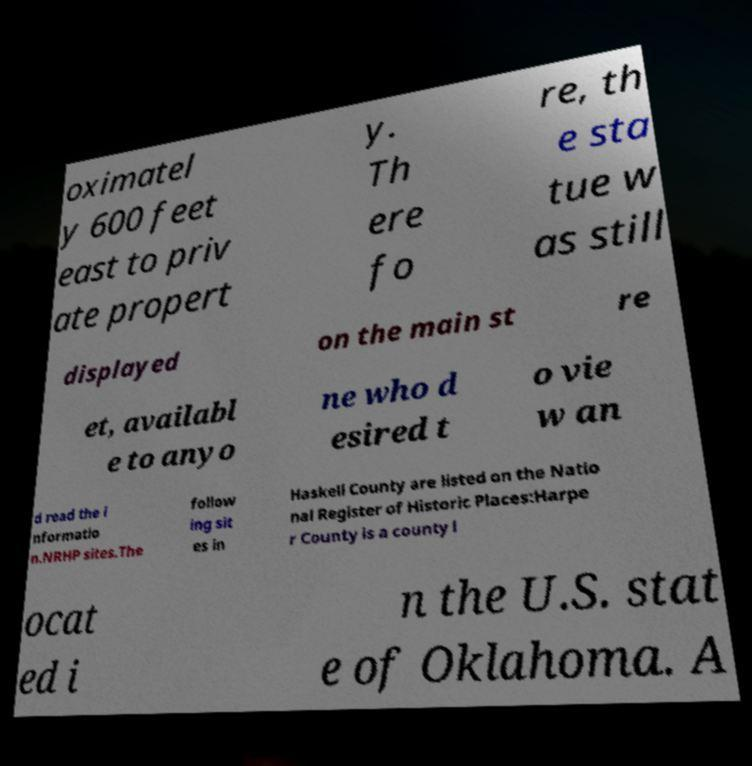Can you read and provide the text displayed in the image?This photo seems to have some interesting text. Can you extract and type it out for me? oximatel y 600 feet east to priv ate propert y. Th ere fo re, th e sta tue w as still displayed on the main st re et, availabl e to anyo ne who d esired t o vie w an d read the i nformatio n.NRHP sites.The follow ing sit es in Haskell County are listed on the Natio nal Register of Historic Places:Harpe r County is a county l ocat ed i n the U.S. stat e of Oklahoma. A 